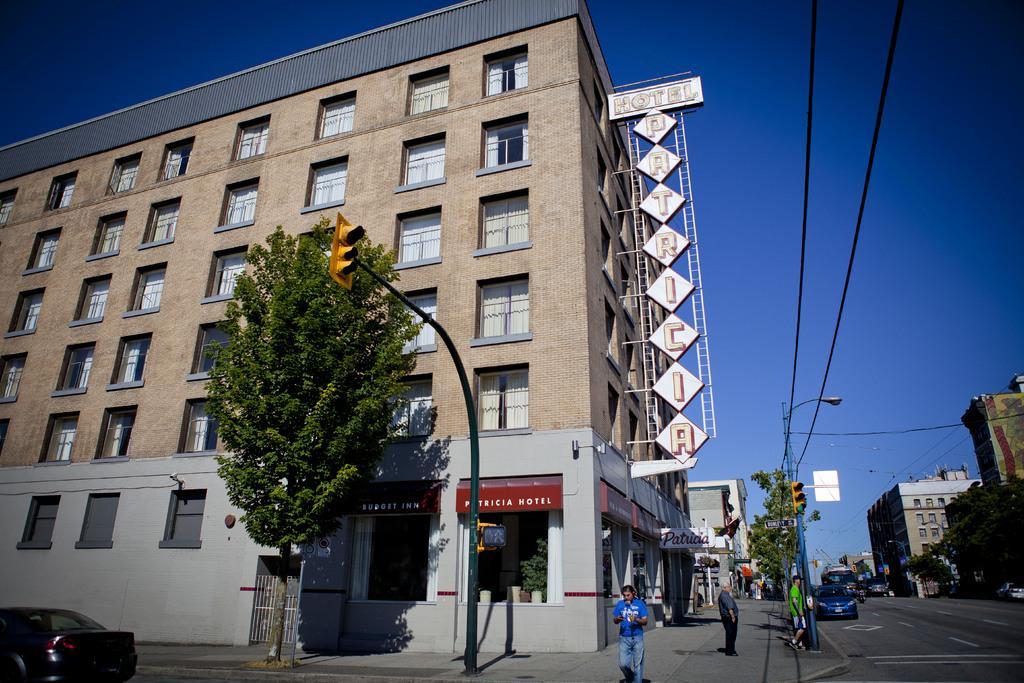How would you summarize this image in a sentence or two? In this image, I can see the buildings, name boards, trees, traffic lights, wires and a street light. At the bottom of the image, I can see few people standing and there are vehicles on the road. In the background, there is the sky. 